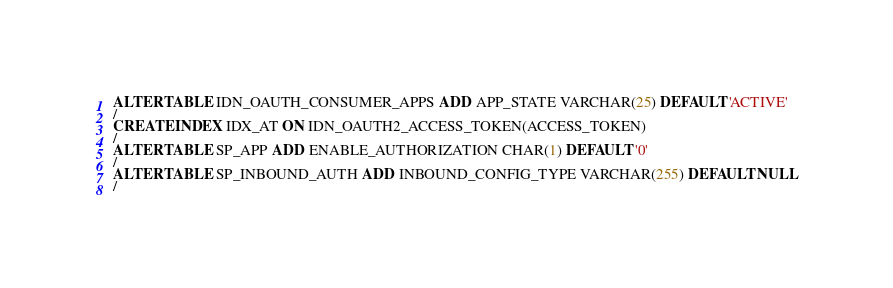Convert code to text. <code><loc_0><loc_0><loc_500><loc_500><_SQL_>ALTER TABLE IDN_OAUTH_CONSUMER_APPS ADD APP_STATE VARCHAR(25) DEFAULT 'ACTIVE'
/
CREATE INDEX IDX_AT ON IDN_OAUTH2_ACCESS_TOKEN(ACCESS_TOKEN)
/
ALTER TABLE SP_APP ADD ENABLE_AUTHORIZATION CHAR(1) DEFAULT '0'
/
ALTER TABLE SP_INBOUND_AUTH ADD INBOUND_CONFIG_TYPE VARCHAR(255) DEFAULT NULL
/</code> 